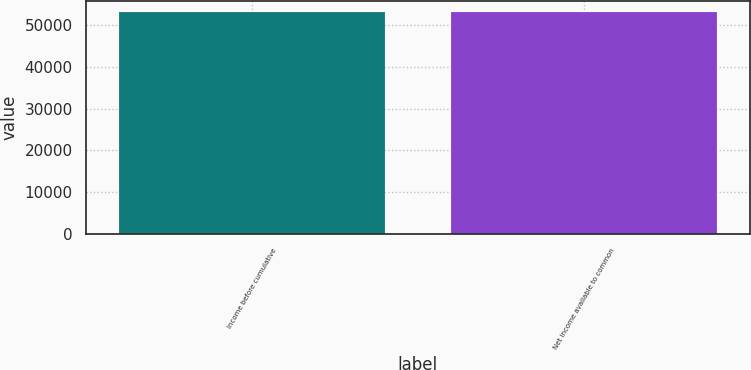<chart> <loc_0><loc_0><loc_500><loc_500><bar_chart><fcel>Income before cumulative<fcel>Net income available to common<nl><fcel>53300<fcel>53300.1<nl></chart> 